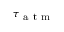Convert formula to latex. <formula><loc_0><loc_0><loc_500><loc_500>\tau _ { a t m }</formula> 